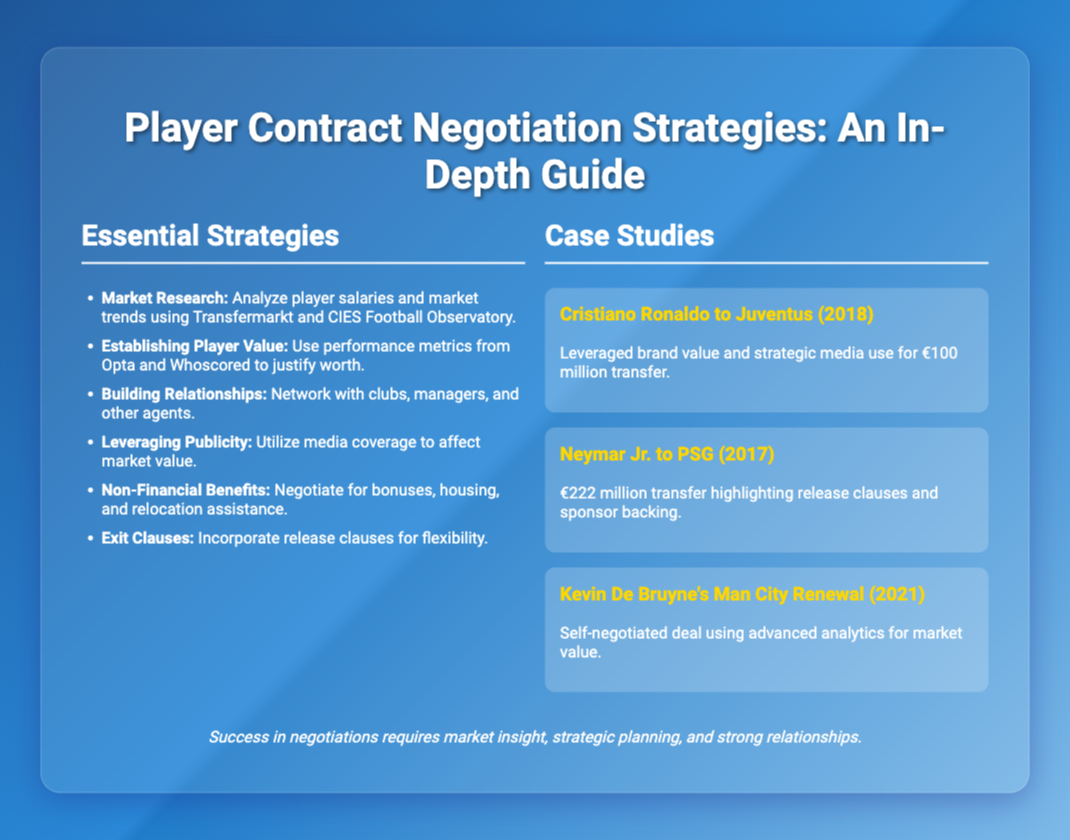What are the essential strategies listed in the presentation? The essential strategies are outlined in the 'Essential Strategies' section, detailing various negotiation tactics.
Answer: Market Research, Establishing Player Value, Building Relationships, Leveraging Publicity, Non-Financial Benefits, Exit Clauses Who was transferred to Juventus in 2018? The case study mentions Cristiano Ronaldo's transfer to Juventus as an example.
Answer: Cristiano Ronaldo What was the transfer fee for Neymar Jr. to PSG? The document provides the transfer fee for Neymar Jr. in the case study about his move to PSG.
Answer: €222 million Which analytics were used by Kevin De Bruyne for his renewal? The case study indicates that Kevin De Bruyne used advanced analytics for negotiating his deal with Man City.
Answer: Advanced analytics What strategy involves media coverage? The essential strategy regarding the use of media coverage in negotiations is highlighted in the document.
Answer: Leveraging Publicity What year was Kevin De Bruyne's Man City renewal? The case study about Kevin De Bruyne specifies the year of his contract renewal.
Answer: 2021 What is the main focus of the presentation? The title of the presentation directly states its main focus on player contract negotiation strategies.
Answer: Player Contract Negotiation Strategies Which player leveraged brand value for a €100 million transfer? The case study discusses a specific player leveraging brand value during their transfer to Juventus.
Answer: Cristiano Ronaldo 